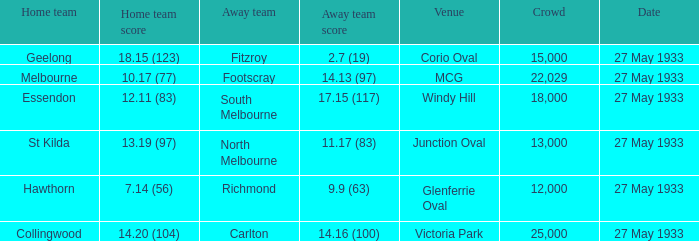In the event where the home team reached 1 25000.0. 